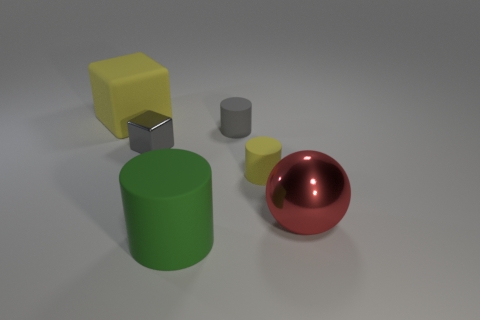There is a gray rubber object; is its shape the same as the big thing that is in front of the large red metallic sphere?
Your response must be concise. Yes. The big block that is the same material as the small yellow cylinder is what color?
Provide a short and direct response. Yellow. How big is the cylinder behind the tiny cube?
Give a very brief answer. Small. Are there fewer gray cylinders behind the tiny metal object than tiny brown rubber cylinders?
Provide a succinct answer. No. Is the color of the big cylinder the same as the metal sphere?
Your answer should be very brief. No. Are there any other things that are the same shape as the small yellow rubber thing?
Provide a succinct answer. Yes. Are there fewer shiny blocks than brown balls?
Your answer should be compact. No. What is the color of the cube that is in front of the yellow rubber thing that is behind the metal block?
Your answer should be compact. Gray. What is the material of the yellow object that is in front of the yellow matte object that is behind the tiny matte cylinder that is in front of the gray cylinder?
Give a very brief answer. Rubber. There is a shiny thing on the right side of the yellow matte cylinder; does it have the same size as the green rubber cylinder?
Provide a short and direct response. Yes. 